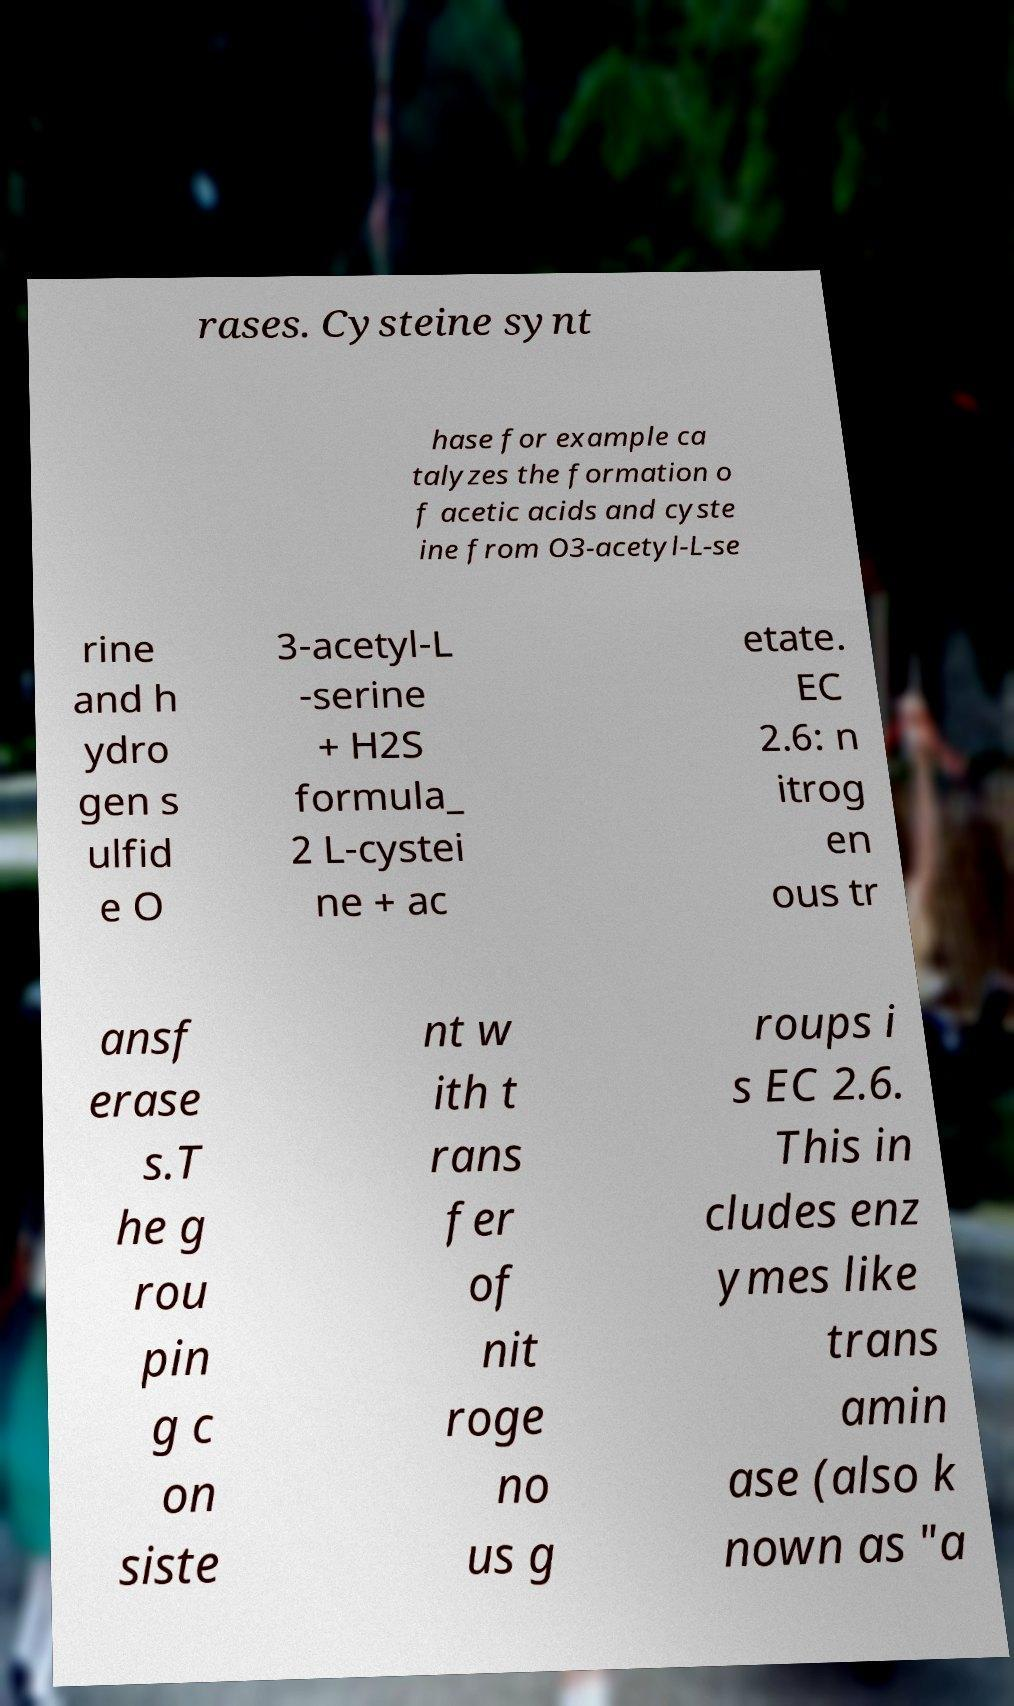For documentation purposes, I need the text within this image transcribed. Could you provide that? rases. Cysteine synt hase for example ca talyzes the formation o f acetic acids and cyste ine from O3-acetyl-L-se rine and h ydro gen s ulfid e O 3-acetyl-L -serine + H2S formula_ 2 L-cystei ne + ac etate. EC 2.6: n itrog en ous tr ansf erase s.T he g rou pin g c on siste nt w ith t rans fer of nit roge no us g roups i s EC 2.6. This in cludes enz ymes like trans amin ase (also k nown as "a 